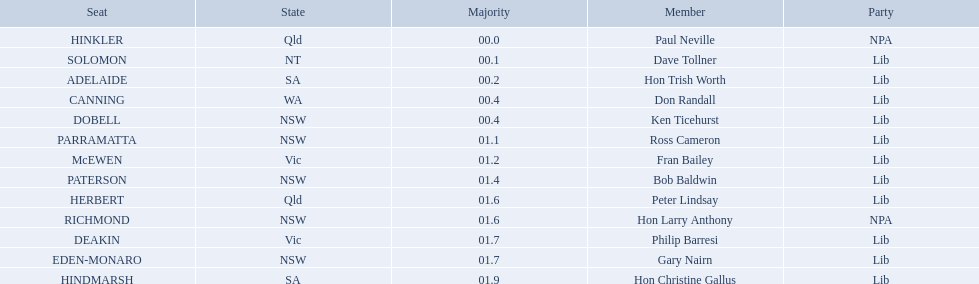What state is hinkler a part of? Qld. What is the primary distinction between sa and qld? 01.9. To which state does hinkler pertain? Qld. What is the chief disparity between sa and qld? 01.9. Who are all the members belonging to the lib party? Dave Tollner, Hon Trish Worth, Don Randall, Ken Ticehurst, Ross Cameron, Fran Bailey, Bob Baldwin, Peter Lindsay, Philip Barresi, Gary Nairn, Hon Christine Gallus. What lib party members are located in sa? Hon Trish Worth, Hon Christine Gallus. What is the greatest difference in majority among members in sa? 01.9. In australia's electoral system, which seats are present? HINKLER, SOLOMON, ADELAIDE, CANNING, DOBELL, PARRAMATTA, McEWEN, PATERSON, HERBERT, RICHMOND, DEAKIN, EDEN-MONARO, HINDMARSH. What were the majority figures for both hindmarsh and hinkler? HINKLER, HINDMARSH. What is the difference in voting majority between these two seats? 01.9. To which state does hinkler belong? Qld. What is the major difference between sa and qld? 01.9. Which state is home to hinkler? Qld. What is the most significant difference between sa and qld? 01.9. 